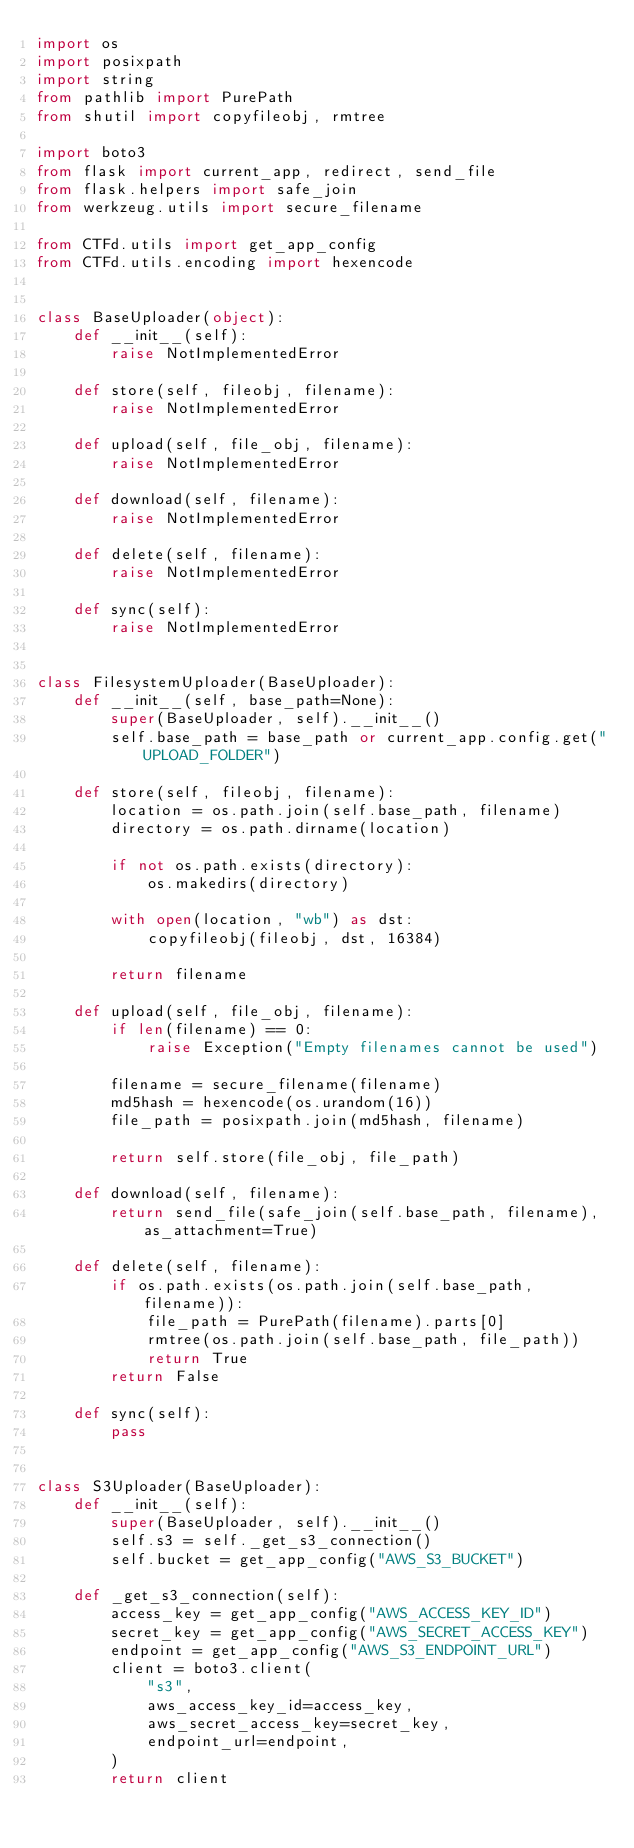Convert code to text. <code><loc_0><loc_0><loc_500><loc_500><_Python_>import os
import posixpath
import string
from pathlib import PurePath
from shutil import copyfileobj, rmtree

import boto3
from flask import current_app, redirect, send_file
from flask.helpers import safe_join
from werkzeug.utils import secure_filename

from CTFd.utils import get_app_config
from CTFd.utils.encoding import hexencode


class BaseUploader(object):
    def __init__(self):
        raise NotImplementedError

    def store(self, fileobj, filename):
        raise NotImplementedError

    def upload(self, file_obj, filename):
        raise NotImplementedError

    def download(self, filename):
        raise NotImplementedError

    def delete(self, filename):
        raise NotImplementedError

    def sync(self):
        raise NotImplementedError


class FilesystemUploader(BaseUploader):
    def __init__(self, base_path=None):
        super(BaseUploader, self).__init__()
        self.base_path = base_path or current_app.config.get("UPLOAD_FOLDER")

    def store(self, fileobj, filename):
        location = os.path.join(self.base_path, filename)
        directory = os.path.dirname(location)

        if not os.path.exists(directory):
            os.makedirs(directory)

        with open(location, "wb") as dst:
            copyfileobj(fileobj, dst, 16384)

        return filename

    def upload(self, file_obj, filename):
        if len(filename) == 0:
            raise Exception("Empty filenames cannot be used")

        filename = secure_filename(filename)
        md5hash = hexencode(os.urandom(16))
        file_path = posixpath.join(md5hash, filename)

        return self.store(file_obj, file_path)

    def download(self, filename):
        return send_file(safe_join(self.base_path, filename), as_attachment=True)

    def delete(self, filename):
        if os.path.exists(os.path.join(self.base_path, filename)):
            file_path = PurePath(filename).parts[0]
            rmtree(os.path.join(self.base_path, file_path))
            return True
        return False

    def sync(self):
        pass


class S3Uploader(BaseUploader):
    def __init__(self):
        super(BaseUploader, self).__init__()
        self.s3 = self._get_s3_connection()
        self.bucket = get_app_config("AWS_S3_BUCKET")

    def _get_s3_connection(self):
        access_key = get_app_config("AWS_ACCESS_KEY_ID")
        secret_key = get_app_config("AWS_SECRET_ACCESS_KEY")
        endpoint = get_app_config("AWS_S3_ENDPOINT_URL")
        client = boto3.client(
            "s3",
            aws_access_key_id=access_key,
            aws_secret_access_key=secret_key,
            endpoint_url=endpoint,
        )
        return client
</code> 